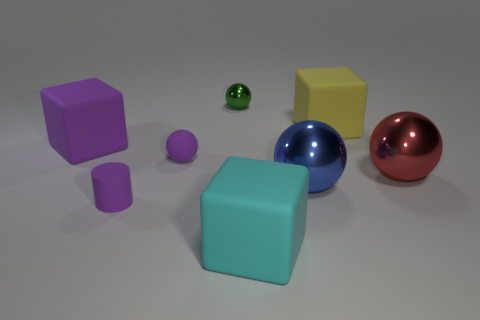How many things are either large shiny balls or large things behind the cyan cube? In the image, there are two large shiny balls, one blue and one red. Additionally, there are two large objects behind the cyan cube: a yellow cube and a pink cube. Therefore, the total count of things that are either large shiny balls or large things behind the cyan cube is four. 